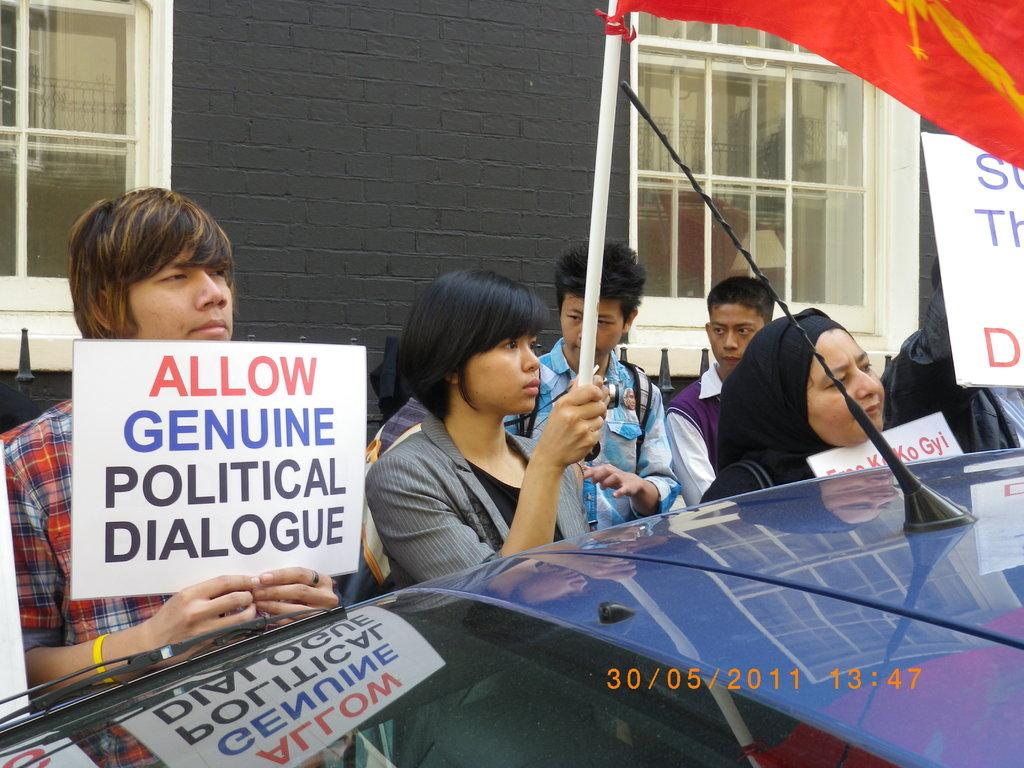Who are the subjects in the image? There are people in the image. What are the people in the image doing? The people are protesting. What are the protesters holding in the image? The protesters are holding posters and banners. What is blocking the path of the protesters in the image? There is a car in front of the protesters. Where are the firemen in the image? There are no firemen present in the image. How are the ants sorting the protestors in the image? There are no ants present in the image, and they cannot sort the protestors. 